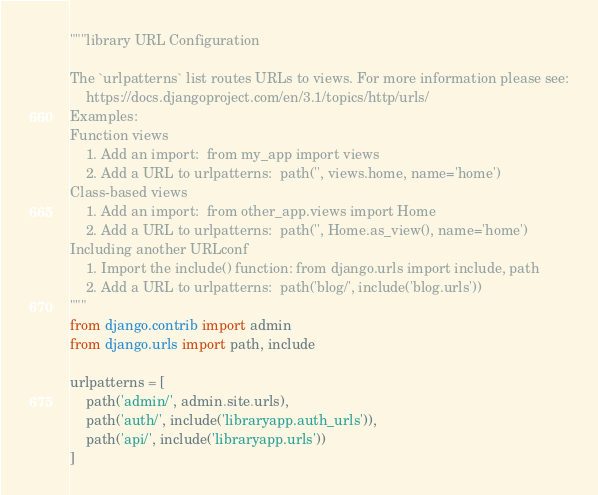<code> <loc_0><loc_0><loc_500><loc_500><_Python_>"""library URL Configuration

The `urlpatterns` list routes URLs to views. For more information please see:
    https://docs.djangoproject.com/en/3.1/topics/http/urls/
Examples:
Function views
    1. Add an import:  from my_app import views
    2. Add a URL to urlpatterns:  path('', views.home, name='home')
Class-based views
    1. Add an import:  from other_app.views import Home
    2. Add a URL to urlpatterns:  path('', Home.as_view(), name='home')
Including another URLconf
    1. Import the include() function: from django.urls import include, path
    2. Add a URL to urlpatterns:  path('blog/', include('blog.urls'))
"""
from django.contrib import admin
from django.urls import path, include

urlpatterns = [
    path('admin/', admin.site.urls),
    path('auth/', include('libraryapp.auth_urls')),
    path('api/', include('libraryapp.urls'))
]
</code> 